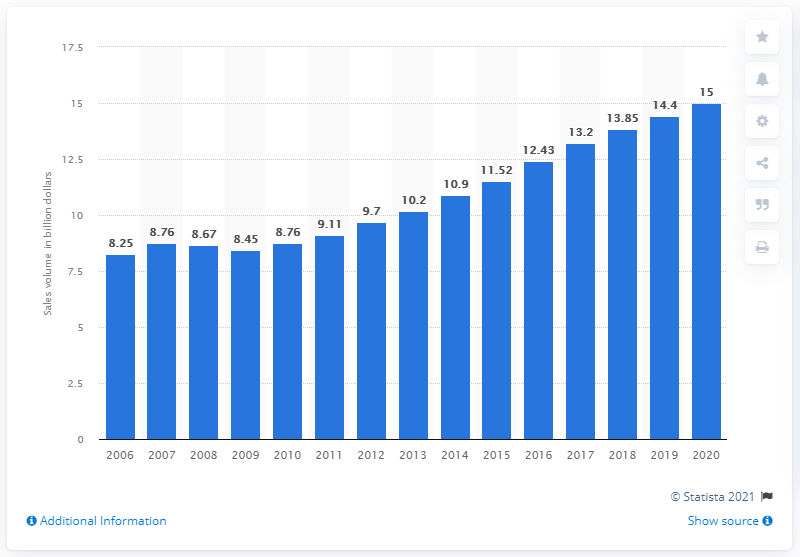Indicate a few pertinent items in this graphic. In the United States in 2020, a significant amount of bottled water was sold. 